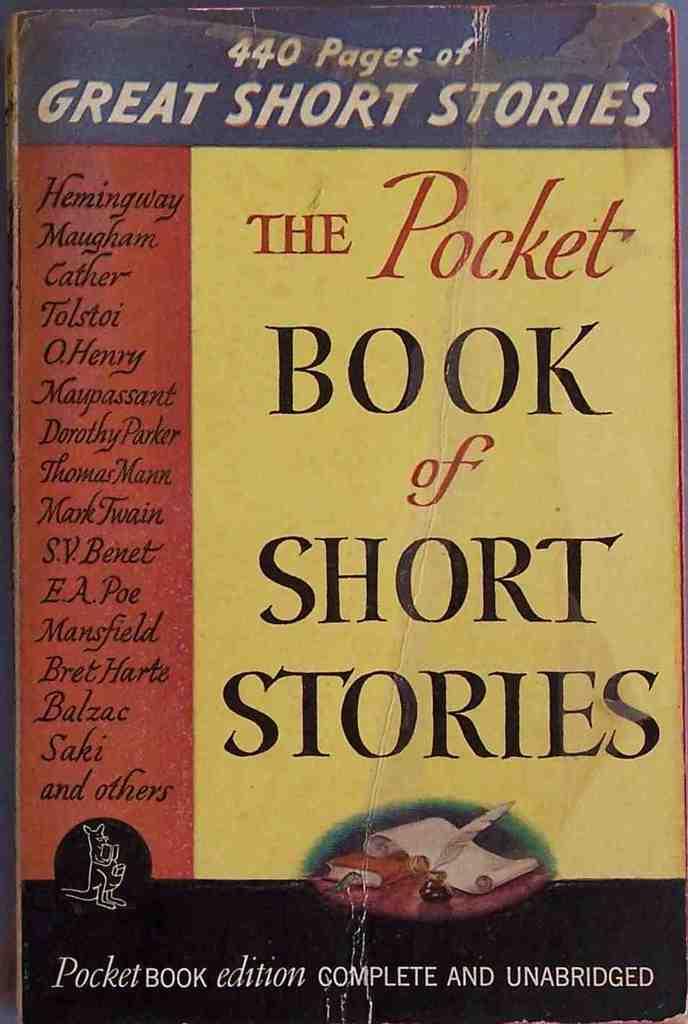How many pages are there?
Give a very brief answer. 440. 